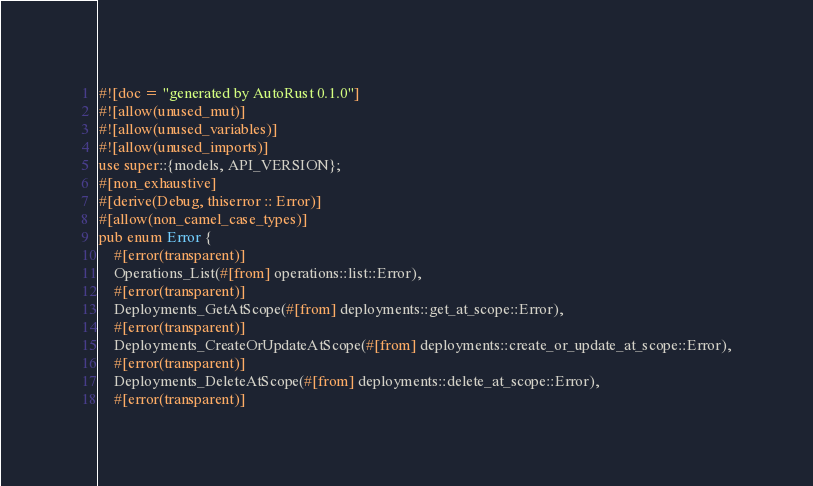<code> <loc_0><loc_0><loc_500><loc_500><_Rust_>#![doc = "generated by AutoRust 0.1.0"]
#![allow(unused_mut)]
#![allow(unused_variables)]
#![allow(unused_imports)]
use super::{models, API_VERSION};
#[non_exhaustive]
#[derive(Debug, thiserror :: Error)]
#[allow(non_camel_case_types)]
pub enum Error {
    #[error(transparent)]
    Operations_List(#[from] operations::list::Error),
    #[error(transparent)]
    Deployments_GetAtScope(#[from] deployments::get_at_scope::Error),
    #[error(transparent)]
    Deployments_CreateOrUpdateAtScope(#[from] deployments::create_or_update_at_scope::Error),
    #[error(transparent)]
    Deployments_DeleteAtScope(#[from] deployments::delete_at_scope::Error),
    #[error(transparent)]</code> 